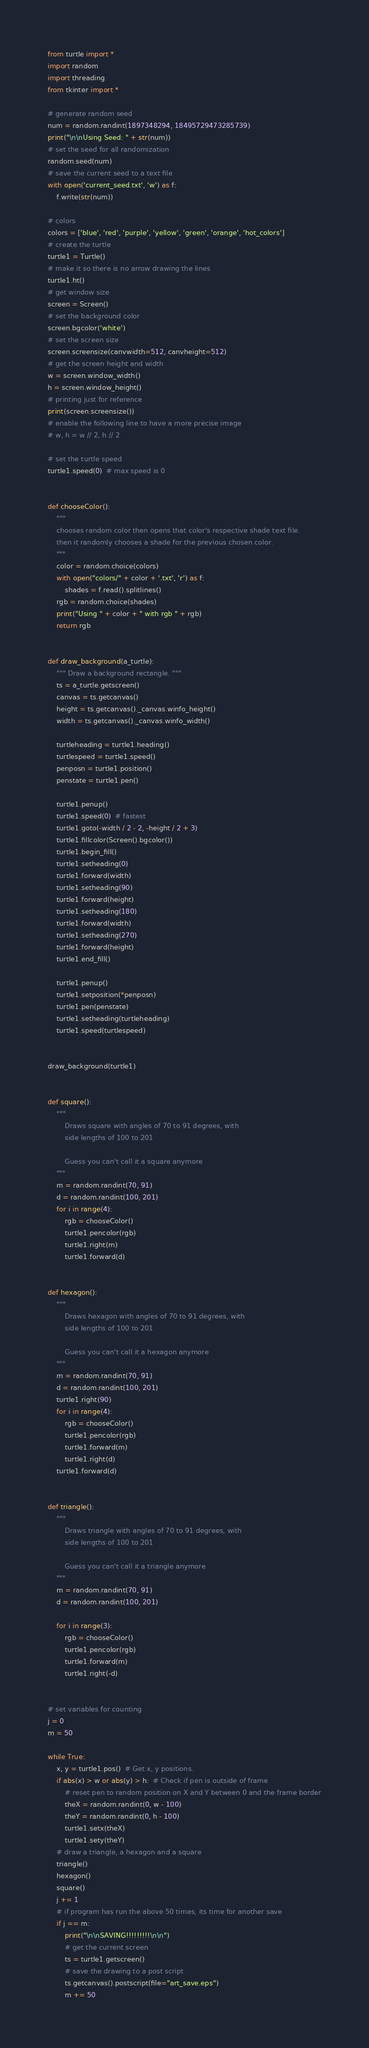<code> <loc_0><loc_0><loc_500><loc_500><_Python_>from turtle import *
import random
import threading
from tkinter import *

# generate random seed
num = random.randint(1897348294, 18495729473285739)
print("\n\nUsing Seed: " + str(num))
# set the seed for all randomization
random.seed(num)
# save the current seed to a text file
with open('current_seed.txt', 'w') as f:
    f.write(str(num))

# colors
colors = ['blue', 'red', 'purple', 'yellow', 'green', 'orange', 'hot_colors']
# create the turtle
turtle1 = Turtle()
# make it so there is no arrow drawing the lines
turtle1.ht()
# get window size
screen = Screen()
# set the background color
screen.bgcolor('white')
# set the screen size
screen.screensize(canvwidth=512, canvheight=512)
# get the screen height and width
w = screen.window_width()
h = screen.window_height()
# printing just for reference
print(screen.screensize())
# enable the following line to have a more precise image
# w, h = w // 2, h // 2

# set the turtle speed
turtle1.speed(0)  # max speed is 0


def chooseColor():
    """
    chooses random color then opens that color's respective shade text file.
    then it randomly chooses a shade for the previous chosen color.
    """
    color = random.choice(colors)
    with open("colors/" + color + '.txt', 'r') as f:
        shades = f.read().splitlines()
    rgb = random.choice(shades)
    print("Using " + color + " with rgb " + rgb)
    return rgb


def draw_background(a_turtle):
    """ Draw a background rectangle. """
    ts = a_turtle.getscreen()
    canvas = ts.getcanvas()
    height = ts.getcanvas()._canvas.winfo_height()
    width = ts.getcanvas()._canvas.winfo_width()

    turtleheading = turtle1.heading()
    turtlespeed = turtle1.speed()
    penposn = turtle1.position()
    penstate = turtle1.pen()

    turtle1.penup()
    turtle1.speed(0)  # fastest
    turtle1.goto(-width / 2 - 2, -height / 2 + 3)
    turtle1.fillcolor(Screen().bgcolor())
    turtle1.begin_fill()
    turtle1.setheading(0)
    turtle1.forward(width)
    turtle1.setheading(90)
    turtle1.forward(height)
    turtle1.setheading(180)
    turtle1.forward(width)
    turtle1.setheading(270)
    turtle1.forward(height)
    turtle1.end_fill()

    turtle1.penup()
    turtle1.setposition(*penposn)
    turtle1.pen(penstate)
    turtle1.setheading(turtleheading)
    turtle1.speed(turtlespeed)


draw_background(turtle1)


def square():
    """
        Draws square with angles of 70 to 91 degrees, with
        side lengths of 100 to 201

        Guess you can't call it a square anymore
    """
    m = random.randint(70, 91)
    d = random.randint(100, 201)
    for i in range(4):
        rgb = chooseColor()
        turtle1.pencolor(rgb)
        turtle1.right(m)
        turtle1.forward(d)


def hexagon():
    """
        Draws hexagon with angles of 70 to 91 degrees, with
        side lengths of 100 to 201

        Guess you can't call it a hexagon anymore
    """
    m = random.randint(70, 91)
    d = random.randint(100, 201)
    turtle1.right(90)
    for i in range(4):
        rgb = chooseColor()
        turtle1.pencolor(rgb)
        turtle1.forward(m)
        turtle1.right(d)
    turtle1.forward(d)


def triangle():
    """
        Draws triangle with angles of 70 to 91 degrees, with
        side lengths of 100 to 201

        Guess you can't call it a triangle anymore
    """
    m = random.randint(70, 91)
    d = random.randint(100, 201)

    for i in range(3):
        rgb = chooseColor()
        turtle1.pencolor(rgb)
        turtle1.forward(m)
        turtle1.right(-d)


# set variables for counting
j = 0
m = 50

while True:
    x, y = turtle1.pos()  # Get x, y positions.
    if abs(x) > w or abs(y) > h:  # Check if pen is outside of frame
        # reset pen to random position on X and Y between 0 and the frame border
        theX = random.randint(0, w - 100)
        theY = random.randint(0, h - 100)
        turtle1.setx(theX)
        turtle1.sety(theY)
    # draw a triangle, a hexagon and a square
    triangle()
    hexagon()
    square()
    j += 1
    # if program has run the above 50 times, its time for another save
    if j == m:
        print("\n\nSAVING!!!!!!!!!\n\n")
        # get the current screen
        ts = turtle1.getscreen()
        # save the drawing to a post script
        ts.getcanvas().postscript(file="art_save.eps")
        m += 50
</code> 